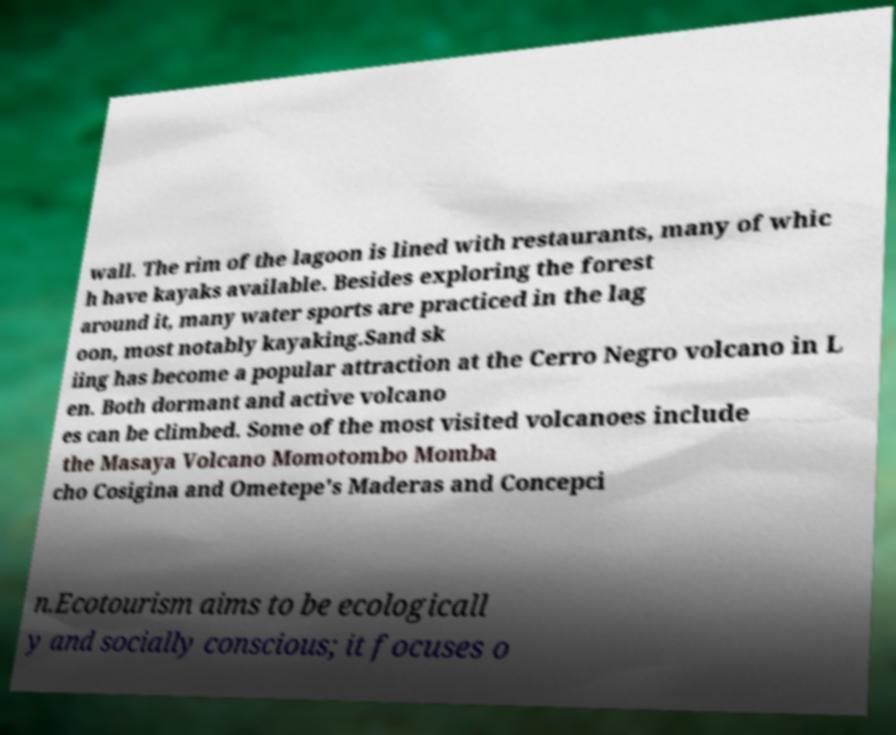Can you accurately transcribe the text from the provided image for me? wall. The rim of the lagoon is lined with restaurants, many of whic h have kayaks available. Besides exploring the forest around it, many water sports are practiced in the lag oon, most notably kayaking.Sand sk iing has become a popular attraction at the Cerro Negro volcano in L en. Both dormant and active volcano es can be climbed. Some of the most visited volcanoes include the Masaya Volcano Momotombo Momba cho Cosigina and Ometepe's Maderas and Concepci n.Ecotourism aims to be ecologicall y and socially conscious; it focuses o 